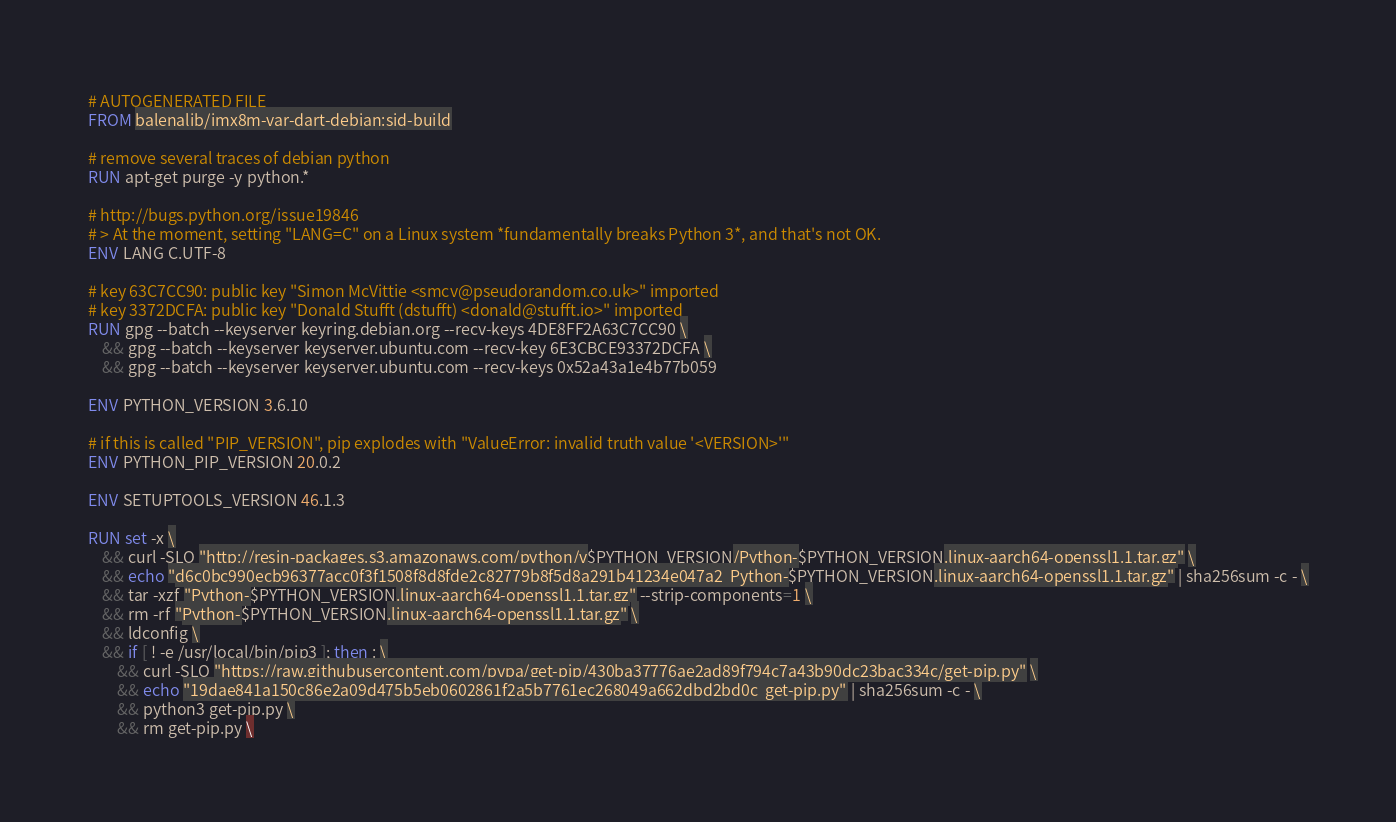<code> <loc_0><loc_0><loc_500><loc_500><_Dockerfile_># AUTOGENERATED FILE
FROM balenalib/imx8m-var-dart-debian:sid-build

# remove several traces of debian python
RUN apt-get purge -y python.*

# http://bugs.python.org/issue19846
# > At the moment, setting "LANG=C" on a Linux system *fundamentally breaks Python 3*, and that's not OK.
ENV LANG C.UTF-8

# key 63C7CC90: public key "Simon McVittie <smcv@pseudorandom.co.uk>" imported
# key 3372DCFA: public key "Donald Stufft (dstufft) <donald@stufft.io>" imported
RUN gpg --batch --keyserver keyring.debian.org --recv-keys 4DE8FF2A63C7CC90 \
	&& gpg --batch --keyserver keyserver.ubuntu.com --recv-key 6E3CBCE93372DCFA \
	&& gpg --batch --keyserver keyserver.ubuntu.com --recv-keys 0x52a43a1e4b77b059

ENV PYTHON_VERSION 3.6.10

# if this is called "PIP_VERSION", pip explodes with "ValueError: invalid truth value '<VERSION>'"
ENV PYTHON_PIP_VERSION 20.0.2

ENV SETUPTOOLS_VERSION 46.1.3

RUN set -x \
	&& curl -SLO "http://resin-packages.s3.amazonaws.com/python/v$PYTHON_VERSION/Python-$PYTHON_VERSION.linux-aarch64-openssl1.1.tar.gz" \
	&& echo "d6c0bc990ecb96377acc0f3f1508f8d8fde2c82779b8f5d8a291b41234e047a2  Python-$PYTHON_VERSION.linux-aarch64-openssl1.1.tar.gz" | sha256sum -c - \
	&& tar -xzf "Python-$PYTHON_VERSION.linux-aarch64-openssl1.1.tar.gz" --strip-components=1 \
	&& rm -rf "Python-$PYTHON_VERSION.linux-aarch64-openssl1.1.tar.gz" \
	&& ldconfig \
	&& if [ ! -e /usr/local/bin/pip3 ]; then : \
		&& curl -SLO "https://raw.githubusercontent.com/pypa/get-pip/430ba37776ae2ad89f794c7a43b90dc23bac334c/get-pip.py" \
		&& echo "19dae841a150c86e2a09d475b5eb0602861f2a5b7761ec268049a662dbd2bd0c  get-pip.py" | sha256sum -c - \
		&& python3 get-pip.py \
		&& rm get-pip.py \</code> 